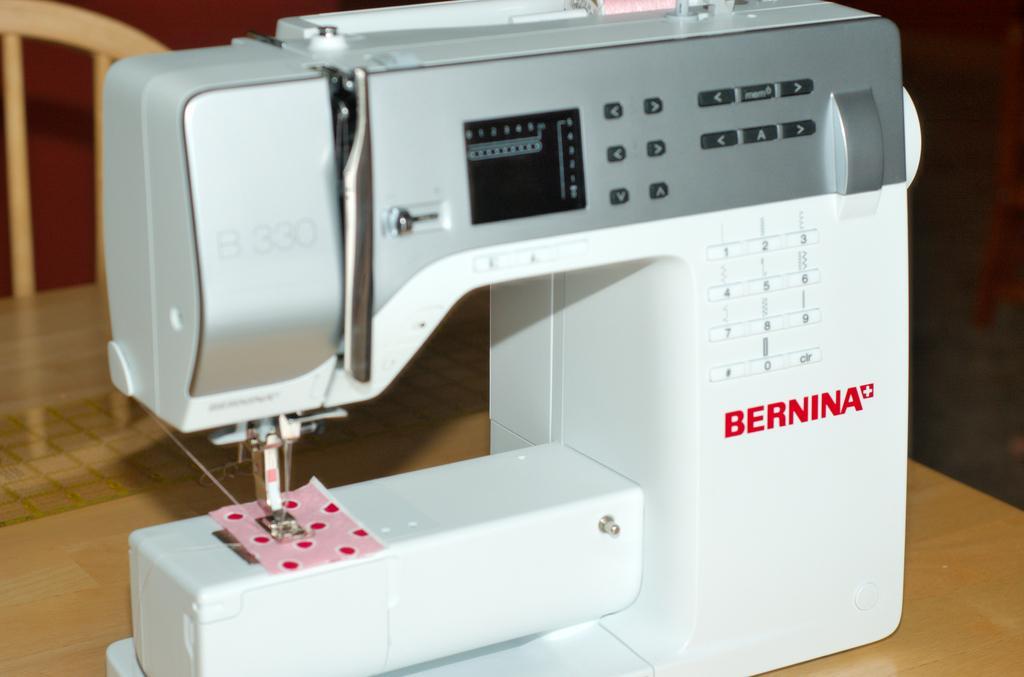Can you describe this image briefly? In this image I can see machine which is in white and ash color. It is on the brown color table and I can see a wooden chair. 